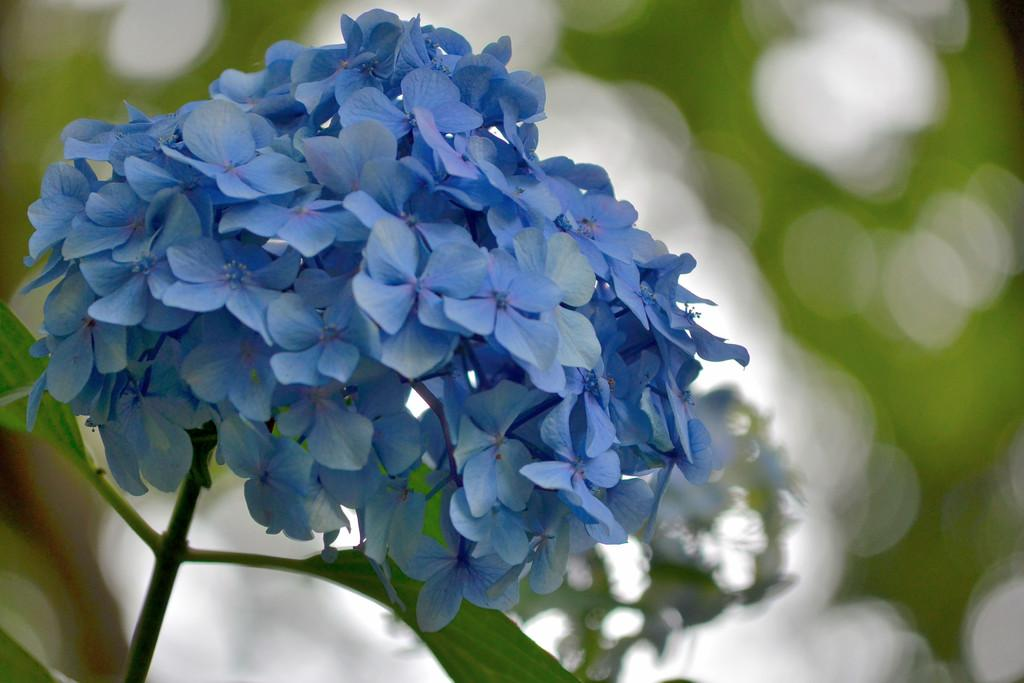What color are the flowers in the image? The flowers in the image are violet. What type of plant do the flowers belong to? The flowers belong to a plant. Can you describe the background of the image? The background of the image is blurry. Who is the owner of the distribution company in the image? There is no distribution company or owner mentioned in the image; it features violet flowers and a blurry background. 